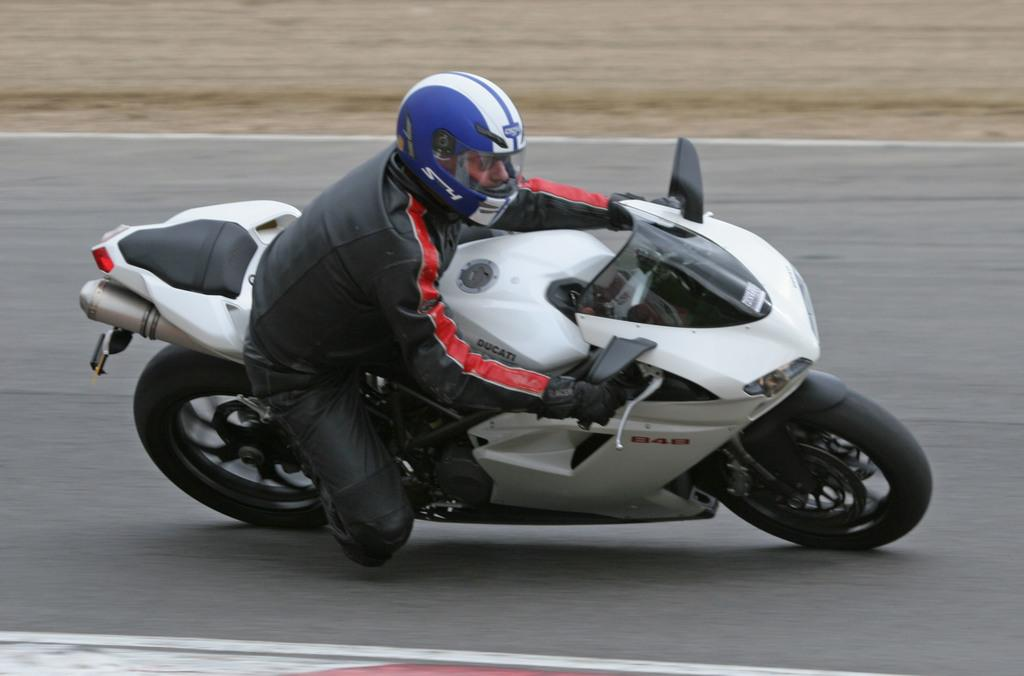What is the main subject of the image? There is a man in the image. What is the man doing in the image? The man is riding a bike in the image. What color is the bike the man is riding? The bike is white in color. What safety gear is the man wearing while riding the bike? The man is wearing a helmet in the image. What color is the helmet the man is wearing? The helmet is blue in color. Where is the bike located in the image? The bike is on the road in the image. Can you see any ghosts attending the party in the image? There is no party or ghosts present in the image; it features a man riding a white bike on the road while wearing a blue helmet. 